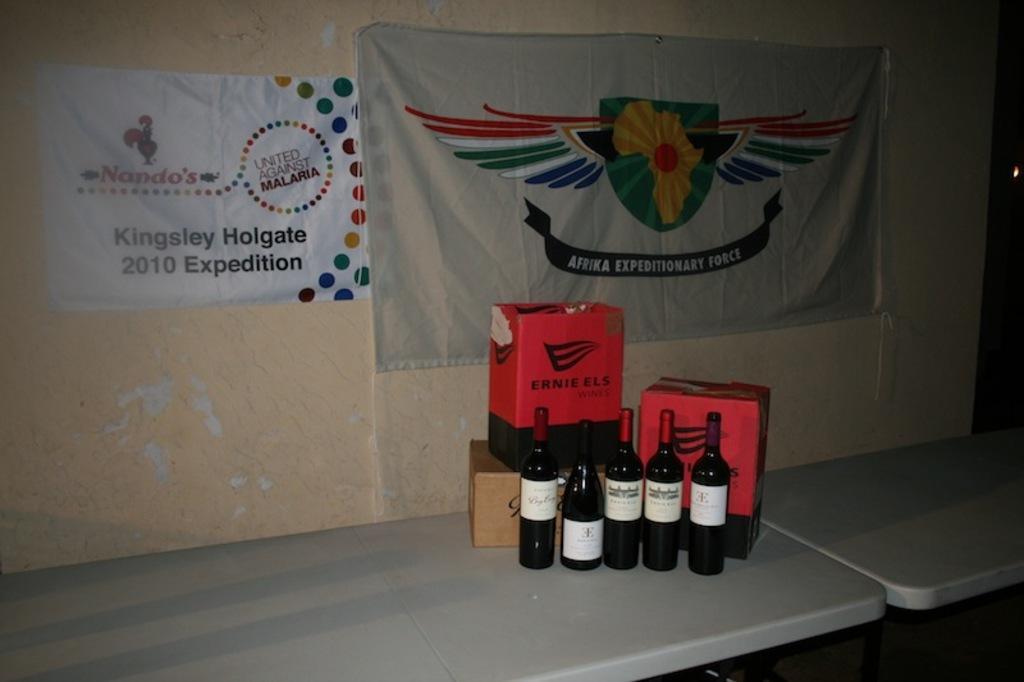Can you describe this image briefly? At the bottom of the image there are tables and we can see bottles and boxes placed on the table. In the background there are banners and a wall. 